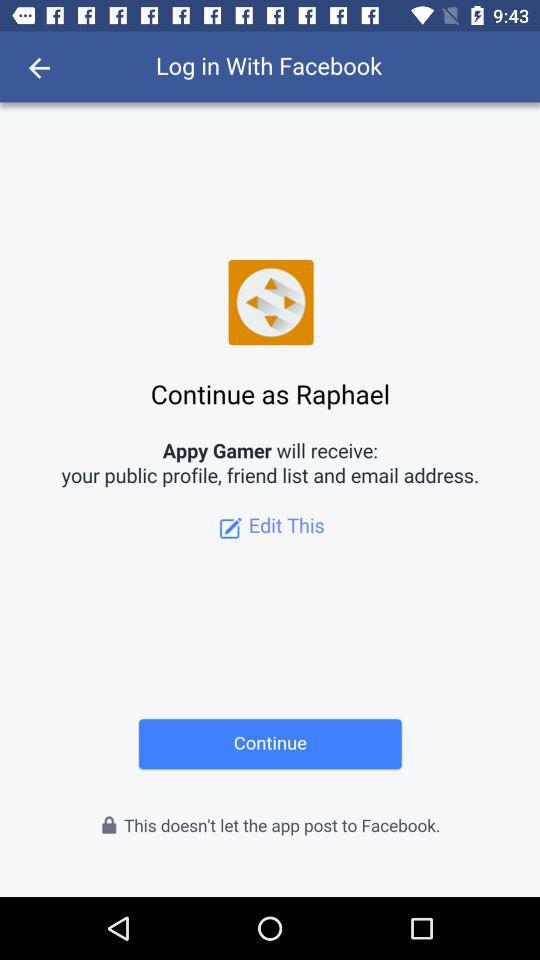What application is asking for permission? The application asking for permission is "Appy Gamer". 